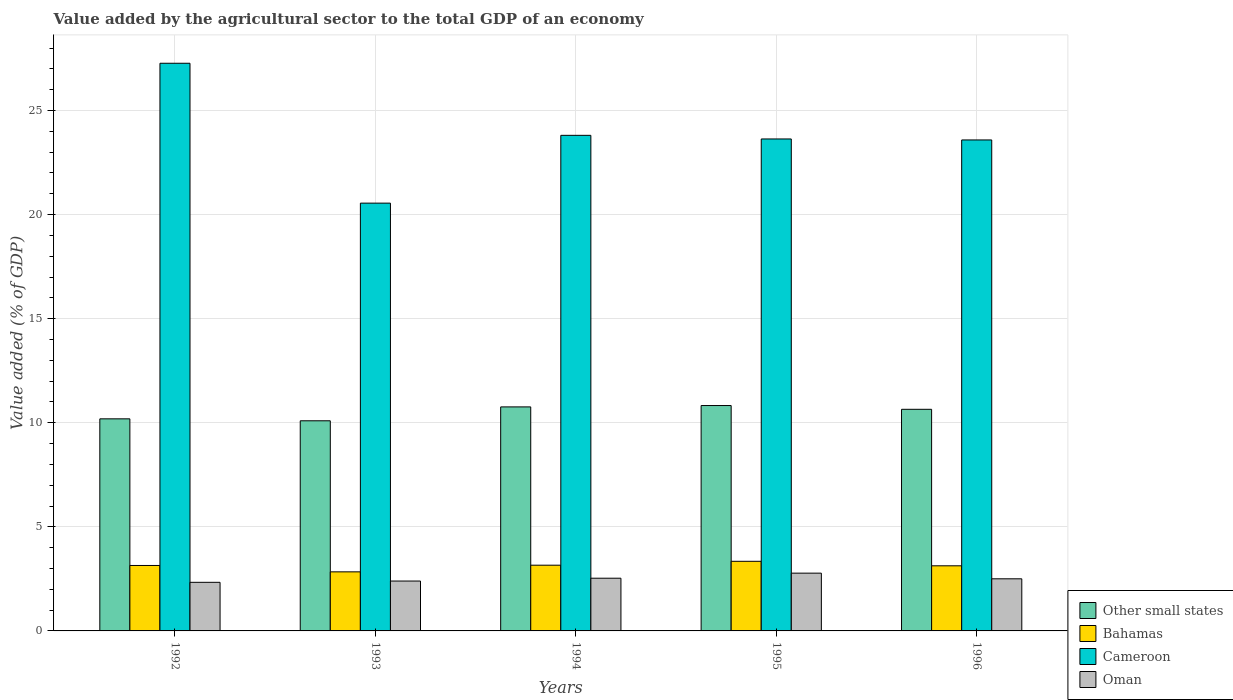Are the number of bars per tick equal to the number of legend labels?
Make the answer very short. Yes. How many bars are there on the 2nd tick from the left?
Offer a terse response. 4. How many bars are there on the 4th tick from the right?
Offer a terse response. 4. What is the label of the 2nd group of bars from the left?
Ensure brevity in your answer.  1993. What is the value added by the agricultural sector to the total GDP in Oman in 1992?
Provide a short and direct response. 2.34. Across all years, what is the maximum value added by the agricultural sector to the total GDP in Oman?
Your answer should be very brief. 2.78. Across all years, what is the minimum value added by the agricultural sector to the total GDP in Oman?
Ensure brevity in your answer.  2.34. What is the total value added by the agricultural sector to the total GDP in Other small states in the graph?
Provide a short and direct response. 52.52. What is the difference between the value added by the agricultural sector to the total GDP in Other small states in 1994 and that in 1995?
Keep it short and to the point. -0.07. What is the difference between the value added by the agricultural sector to the total GDP in Oman in 1992 and the value added by the agricultural sector to the total GDP in Other small states in 1995?
Offer a terse response. -8.49. What is the average value added by the agricultural sector to the total GDP in Oman per year?
Provide a short and direct response. 2.51. In the year 1993, what is the difference between the value added by the agricultural sector to the total GDP in Bahamas and value added by the agricultural sector to the total GDP in Oman?
Give a very brief answer. 0.44. In how many years, is the value added by the agricultural sector to the total GDP in Cameroon greater than 18 %?
Your answer should be very brief. 5. What is the ratio of the value added by the agricultural sector to the total GDP in Other small states in 1993 to that in 1994?
Make the answer very short. 0.94. Is the value added by the agricultural sector to the total GDP in Bahamas in 1993 less than that in 1996?
Make the answer very short. Yes. What is the difference between the highest and the second highest value added by the agricultural sector to the total GDP in Bahamas?
Make the answer very short. 0.19. What is the difference between the highest and the lowest value added by the agricultural sector to the total GDP in Cameroon?
Make the answer very short. 6.72. In how many years, is the value added by the agricultural sector to the total GDP in Cameroon greater than the average value added by the agricultural sector to the total GDP in Cameroon taken over all years?
Keep it short and to the point. 2. Is the sum of the value added by the agricultural sector to the total GDP in Bahamas in 1994 and 1996 greater than the maximum value added by the agricultural sector to the total GDP in Other small states across all years?
Keep it short and to the point. No. What does the 4th bar from the left in 1992 represents?
Make the answer very short. Oman. What does the 1st bar from the right in 1996 represents?
Your answer should be very brief. Oman. Is it the case that in every year, the sum of the value added by the agricultural sector to the total GDP in Cameroon and value added by the agricultural sector to the total GDP in Bahamas is greater than the value added by the agricultural sector to the total GDP in Oman?
Provide a short and direct response. Yes. How many bars are there?
Provide a succinct answer. 20. Does the graph contain any zero values?
Offer a terse response. No. Does the graph contain grids?
Your answer should be compact. Yes. How many legend labels are there?
Keep it short and to the point. 4. What is the title of the graph?
Offer a terse response. Value added by the agricultural sector to the total GDP of an economy. What is the label or title of the X-axis?
Give a very brief answer. Years. What is the label or title of the Y-axis?
Offer a terse response. Value added (% of GDP). What is the Value added (% of GDP) of Other small states in 1992?
Ensure brevity in your answer.  10.19. What is the Value added (% of GDP) of Bahamas in 1992?
Your response must be concise. 3.14. What is the Value added (% of GDP) of Cameroon in 1992?
Make the answer very short. 27.27. What is the Value added (% of GDP) of Oman in 1992?
Provide a short and direct response. 2.34. What is the Value added (% of GDP) of Other small states in 1993?
Provide a succinct answer. 10.1. What is the Value added (% of GDP) in Bahamas in 1993?
Keep it short and to the point. 2.84. What is the Value added (% of GDP) in Cameroon in 1993?
Make the answer very short. 20.55. What is the Value added (% of GDP) in Oman in 1993?
Give a very brief answer. 2.4. What is the Value added (% of GDP) of Other small states in 1994?
Your response must be concise. 10.76. What is the Value added (% of GDP) in Bahamas in 1994?
Ensure brevity in your answer.  3.16. What is the Value added (% of GDP) of Cameroon in 1994?
Provide a succinct answer. 23.81. What is the Value added (% of GDP) of Oman in 1994?
Provide a succinct answer. 2.53. What is the Value added (% of GDP) of Other small states in 1995?
Your answer should be compact. 10.83. What is the Value added (% of GDP) of Bahamas in 1995?
Offer a very short reply. 3.34. What is the Value added (% of GDP) in Cameroon in 1995?
Ensure brevity in your answer.  23.63. What is the Value added (% of GDP) in Oman in 1995?
Provide a succinct answer. 2.78. What is the Value added (% of GDP) of Other small states in 1996?
Provide a short and direct response. 10.65. What is the Value added (% of GDP) of Bahamas in 1996?
Offer a terse response. 3.13. What is the Value added (% of GDP) in Cameroon in 1996?
Provide a short and direct response. 23.59. What is the Value added (% of GDP) of Oman in 1996?
Give a very brief answer. 2.5. Across all years, what is the maximum Value added (% of GDP) of Other small states?
Offer a very short reply. 10.83. Across all years, what is the maximum Value added (% of GDP) of Bahamas?
Offer a terse response. 3.34. Across all years, what is the maximum Value added (% of GDP) of Cameroon?
Offer a very short reply. 27.27. Across all years, what is the maximum Value added (% of GDP) in Oman?
Give a very brief answer. 2.78. Across all years, what is the minimum Value added (% of GDP) in Other small states?
Your response must be concise. 10.1. Across all years, what is the minimum Value added (% of GDP) of Bahamas?
Provide a short and direct response. 2.84. Across all years, what is the minimum Value added (% of GDP) in Cameroon?
Provide a short and direct response. 20.55. Across all years, what is the minimum Value added (% of GDP) of Oman?
Provide a short and direct response. 2.34. What is the total Value added (% of GDP) of Other small states in the graph?
Your response must be concise. 52.52. What is the total Value added (% of GDP) of Bahamas in the graph?
Provide a short and direct response. 15.61. What is the total Value added (% of GDP) of Cameroon in the graph?
Provide a short and direct response. 118.85. What is the total Value added (% of GDP) in Oman in the graph?
Keep it short and to the point. 12.54. What is the difference between the Value added (% of GDP) of Other small states in 1992 and that in 1993?
Offer a terse response. 0.09. What is the difference between the Value added (% of GDP) in Bahamas in 1992 and that in 1993?
Offer a terse response. 0.31. What is the difference between the Value added (% of GDP) in Cameroon in 1992 and that in 1993?
Keep it short and to the point. 6.72. What is the difference between the Value added (% of GDP) of Oman in 1992 and that in 1993?
Provide a succinct answer. -0.06. What is the difference between the Value added (% of GDP) in Other small states in 1992 and that in 1994?
Provide a succinct answer. -0.57. What is the difference between the Value added (% of GDP) of Bahamas in 1992 and that in 1994?
Your answer should be compact. -0.01. What is the difference between the Value added (% of GDP) of Cameroon in 1992 and that in 1994?
Provide a succinct answer. 3.46. What is the difference between the Value added (% of GDP) in Oman in 1992 and that in 1994?
Offer a very short reply. -0.2. What is the difference between the Value added (% of GDP) of Other small states in 1992 and that in 1995?
Provide a short and direct response. -0.64. What is the difference between the Value added (% of GDP) in Bahamas in 1992 and that in 1995?
Ensure brevity in your answer.  -0.2. What is the difference between the Value added (% of GDP) of Cameroon in 1992 and that in 1995?
Give a very brief answer. 3.64. What is the difference between the Value added (% of GDP) of Oman in 1992 and that in 1995?
Ensure brevity in your answer.  -0.44. What is the difference between the Value added (% of GDP) of Other small states in 1992 and that in 1996?
Provide a short and direct response. -0.46. What is the difference between the Value added (% of GDP) in Bahamas in 1992 and that in 1996?
Make the answer very short. 0.02. What is the difference between the Value added (% of GDP) in Cameroon in 1992 and that in 1996?
Your response must be concise. 3.68. What is the difference between the Value added (% of GDP) in Oman in 1992 and that in 1996?
Offer a very short reply. -0.17. What is the difference between the Value added (% of GDP) in Other small states in 1993 and that in 1994?
Make the answer very short. -0.67. What is the difference between the Value added (% of GDP) of Bahamas in 1993 and that in 1994?
Keep it short and to the point. -0.32. What is the difference between the Value added (% of GDP) of Cameroon in 1993 and that in 1994?
Your response must be concise. -3.26. What is the difference between the Value added (% of GDP) in Oman in 1993 and that in 1994?
Ensure brevity in your answer.  -0.14. What is the difference between the Value added (% of GDP) of Other small states in 1993 and that in 1995?
Offer a very short reply. -0.73. What is the difference between the Value added (% of GDP) of Bahamas in 1993 and that in 1995?
Keep it short and to the point. -0.51. What is the difference between the Value added (% of GDP) of Cameroon in 1993 and that in 1995?
Keep it short and to the point. -3.08. What is the difference between the Value added (% of GDP) of Oman in 1993 and that in 1995?
Provide a succinct answer. -0.38. What is the difference between the Value added (% of GDP) in Other small states in 1993 and that in 1996?
Offer a very short reply. -0.55. What is the difference between the Value added (% of GDP) of Bahamas in 1993 and that in 1996?
Offer a terse response. -0.29. What is the difference between the Value added (% of GDP) of Cameroon in 1993 and that in 1996?
Your response must be concise. -3.04. What is the difference between the Value added (% of GDP) of Oman in 1993 and that in 1996?
Your answer should be compact. -0.11. What is the difference between the Value added (% of GDP) of Other small states in 1994 and that in 1995?
Your response must be concise. -0.07. What is the difference between the Value added (% of GDP) in Bahamas in 1994 and that in 1995?
Give a very brief answer. -0.19. What is the difference between the Value added (% of GDP) of Cameroon in 1994 and that in 1995?
Your answer should be compact. 0.17. What is the difference between the Value added (% of GDP) in Oman in 1994 and that in 1995?
Give a very brief answer. -0.24. What is the difference between the Value added (% of GDP) in Other small states in 1994 and that in 1996?
Offer a terse response. 0.12. What is the difference between the Value added (% of GDP) in Bahamas in 1994 and that in 1996?
Your answer should be compact. 0.03. What is the difference between the Value added (% of GDP) of Cameroon in 1994 and that in 1996?
Offer a very short reply. 0.22. What is the difference between the Value added (% of GDP) in Oman in 1994 and that in 1996?
Your answer should be compact. 0.03. What is the difference between the Value added (% of GDP) of Other small states in 1995 and that in 1996?
Make the answer very short. 0.18. What is the difference between the Value added (% of GDP) in Bahamas in 1995 and that in 1996?
Ensure brevity in your answer.  0.22. What is the difference between the Value added (% of GDP) in Cameroon in 1995 and that in 1996?
Offer a very short reply. 0.05. What is the difference between the Value added (% of GDP) of Oman in 1995 and that in 1996?
Give a very brief answer. 0.27. What is the difference between the Value added (% of GDP) of Other small states in 1992 and the Value added (% of GDP) of Bahamas in 1993?
Provide a succinct answer. 7.35. What is the difference between the Value added (% of GDP) of Other small states in 1992 and the Value added (% of GDP) of Cameroon in 1993?
Make the answer very short. -10.36. What is the difference between the Value added (% of GDP) in Other small states in 1992 and the Value added (% of GDP) in Oman in 1993?
Your answer should be very brief. 7.79. What is the difference between the Value added (% of GDP) of Bahamas in 1992 and the Value added (% of GDP) of Cameroon in 1993?
Give a very brief answer. -17.41. What is the difference between the Value added (% of GDP) of Bahamas in 1992 and the Value added (% of GDP) of Oman in 1993?
Keep it short and to the point. 0.75. What is the difference between the Value added (% of GDP) of Cameroon in 1992 and the Value added (% of GDP) of Oman in 1993?
Your answer should be compact. 24.88. What is the difference between the Value added (% of GDP) in Other small states in 1992 and the Value added (% of GDP) in Bahamas in 1994?
Offer a very short reply. 7.03. What is the difference between the Value added (% of GDP) of Other small states in 1992 and the Value added (% of GDP) of Cameroon in 1994?
Provide a short and direct response. -13.62. What is the difference between the Value added (% of GDP) in Other small states in 1992 and the Value added (% of GDP) in Oman in 1994?
Keep it short and to the point. 7.66. What is the difference between the Value added (% of GDP) in Bahamas in 1992 and the Value added (% of GDP) in Cameroon in 1994?
Offer a terse response. -20.66. What is the difference between the Value added (% of GDP) of Bahamas in 1992 and the Value added (% of GDP) of Oman in 1994?
Keep it short and to the point. 0.61. What is the difference between the Value added (% of GDP) of Cameroon in 1992 and the Value added (% of GDP) of Oman in 1994?
Your answer should be very brief. 24.74. What is the difference between the Value added (% of GDP) of Other small states in 1992 and the Value added (% of GDP) of Bahamas in 1995?
Offer a terse response. 6.84. What is the difference between the Value added (% of GDP) in Other small states in 1992 and the Value added (% of GDP) in Cameroon in 1995?
Your answer should be compact. -13.45. What is the difference between the Value added (% of GDP) in Other small states in 1992 and the Value added (% of GDP) in Oman in 1995?
Give a very brief answer. 7.41. What is the difference between the Value added (% of GDP) of Bahamas in 1992 and the Value added (% of GDP) of Cameroon in 1995?
Make the answer very short. -20.49. What is the difference between the Value added (% of GDP) in Bahamas in 1992 and the Value added (% of GDP) in Oman in 1995?
Your answer should be compact. 0.37. What is the difference between the Value added (% of GDP) in Cameroon in 1992 and the Value added (% of GDP) in Oman in 1995?
Your answer should be very brief. 24.5. What is the difference between the Value added (% of GDP) in Other small states in 1992 and the Value added (% of GDP) in Bahamas in 1996?
Provide a succinct answer. 7.06. What is the difference between the Value added (% of GDP) in Other small states in 1992 and the Value added (% of GDP) in Cameroon in 1996?
Provide a short and direct response. -13.4. What is the difference between the Value added (% of GDP) of Other small states in 1992 and the Value added (% of GDP) of Oman in 1996?
Make the answer very short. 7.68. What is the difference between the Value added (% of GDP) of Bahamas in 1992 and the Value added (% of GDP) of Cameroon in 1996?
Make the answer very short. -20.44. What is the difference between the Value added (% of GDP) in Bahamas in 1992 and the Value added (% of GDP) in Oman in 1996?
Your answer should be very brief. 0.64. What is the difference between the Value added (% of GDP) of Cameroon in 1992 and the Value added (% of GDP) of Oman in 1996?
Make the answer very short. 24.77. What is the difference between the Value added (% of GDP) of Other small states in 1993 and the Value added (% of GDP) of Bahamas in 1994?
Give a very brief answer. 6.94. What is the difference between the Value added (% of GDP) in Other small states in 1993 and the Value added (% of GDP) in Cameroon in 1994?
Provide a succinct answer. -13.71. What is the difference between the Value added (% of GDP) in Other small states in 1993 and the Value added (% of GDP) in Oman in 1994?
Make the answer very short. 7.56. What is the difference between the Value added (% of GDP) in Bahamas in 1993 and the Value added (% of GDP) in Cameroon in 1994?
Your response must be concise. -20.97. What is the difference between the Value added (% of GDP) of Bahamas in 1993 and the Value added (% of GDP) of Oman in 1994?
Provide a short and direct response. 0.31. What is the difference between the Value added (% of GDP) of Cameroon in 1993 and the Value added (% of GDP) of Oman in 1994?
Offer a terse response. 18.02. What is the difference between the Value added (% of GDP) in Other small states in 1993 and the Value added (% of GDP) in Bahamas in 1995?
Ensure brevity in your answer.  6.75. What is the difference between the Value added (% of GDP) in Other small states in 1993 and the Value added (% of GDP) in Cameroon in 1995?
Provide a short and direct response. -13.54. What is the difference between the Value added (% of GDP) of Other small states in 1993 and the Value added (% of GDP) of Oman in 1995?
Your response must be concise. 7.32. What is the difference between the Value added (% of GDP) in Bahamas in 1993 and the Value added (% of GDP) in Cameroon in 1995?
Make the answer very short. -20.8. What is the difference between the Value added (% of GDP) in Bahamas in 1993 and the Value added (% of GDP) in Oman in 1995?
Your answer should be compact. 0.06. What is the difference between the Value added (% of GDP) of Cameroon in 1993 and the Value added (% of GDP) of Oman in 1995?
Your answer should be very brief. 17.78. What is the difference between the Value added (% of GDP) of Other small states in 1993 and the Value added (% of GDP) of Bahamas in 1996?
Your response must be concise. 6.97. What is the difference between the Value added (% of GDP) of Other small states in 1993 and the Value added (% of GDP) of Cameroon in 1996?
Offer a very short reply. -13.49. What is the difference between the Value added (% of GDP) of Other small states in 1993 and the Value added (% of GDP) of Oman in 1996?
Your answer should be compact. 7.59. What is the difference between the Value added (% of GDP) of Bahamas in 1993 and the Value added (% of GDP) of Cameroon in 1996?
Offer a very short reply. -20.75. What is the difference between the Value added (% of GDP) of Bahamas in 1993 and the Value added (% of GDP) of Oman in 1996?
Your answer should be very brief. 0.33. What is the difference between the Value added (% of GDP) in Cameroon in 1993 and the Value added (% of GDP) in Oman in 1996?
Your answer should be compact. 18.05. What is the difference between the Value added (% of GDP) of Other small states in 1994 and the Value added (% of GDP) of Bahamas in 1995?
Offer a terse response. 7.42. What is the difference between the Value added (% of GDP) in Other small states in 1994 and the Value added (% of GDP) in Cameroon in 1995?
Offer a very short reply. -12.87. What is the difference between the Value added (% of GDP) of Other small states in 1994 and the Value added (% of GDP) of Oman in 1995?
Make the answer very short. 7.99. What is the difference between the Value added (% of GDP) of Bahamas in 1994 and the Value added (% of GDP) of Cameroon in 1995?
Give a very brief answer. -20.48. What is the difference between the Value added (% of GDP) in Bahamas in 1994 and the Value added (% of GDP) in Oman in 1995?
Make the answer very short. 0.38. What is the difference between the Value added (% of GDP) of Cameroon in 1994 and the Value added (% of GDP) of Oman in 1995?
Keep it short and to the point. 21.03. What is the difference between the Value added (% of GDP) of Other small states in 1994 and the Value added (% of GDP) of Bahamas in 1996?
Provide a succinct answer. 7.63. What is the difference between the Value added (% of GDP) in Other small states in 1994 and the Value added (% of GDP) in Cameroon in 1996?
Offer a very short reply. -12.82. What is the difference between the Value added (% of GDP) in Other small states in 1994 and the Value added (% of GDP) in Oman in 1996?
Ensure brevity in your answer.  8.26. What is the difference between the Value added (% of GDP) in Bahamas in 1994 and the Value added (% of GDP) in Cameroon in 1996?
Make the answer very short. -20.43. What is the difference between the Value added (% of GDP) in Bahamas in 1994 and the Value added (% of GDP) in Oman in 1996?
Offer a very short reply. 0.65. What is the difference between the Value added (% of GDP) of Cameroon in 1994 and the Value added (% of GDP) of Oman in 1996?
Give a very brief answer. 21.3. What is the difference between the Value added (% of GDP) of Other small states in 1995 and the Value added (% of GDP) of Bahamas in 1996?
Your answer should be compact. 7.7. What is the difference between the Value added (% of GDP) of Other small states in 1995 and the Value added (% of GDP) of Cameroon in 1996?
Provide a short and direct response. -12.76. What is the difference between the Value added (% of GDP) of Other small states in 1995 and the Value added (% of GDP) of Oman in 1996?
Give a very brief answer. 8.32. What is the difference between the Value added (% of GDP) of Bahamas in 1995 and the Value added (% of GDP) of Cameroon in 1996?
Provide a short and direct response. -20.24. What is the difference between the Value added (% of GDP) in Bahamas in 1995 and the Value added (% of GDP) in Oman in 1996?
Make the answer very short. 0.84. What is the difference between the Value added (% of GDP) in Cameroon in 1995 and the Value added (% of GDP) in Oman in 1996?
Keep it short and to the point. 21.13. What is the average Value added (% of GDP) in Other small states per year?
Provide a short and direct response. 10.5. What is the average Value added (% of GDP) of Bahamas per year?
Give a very brief answer. 3.12. What is the average Value added (% of GDP) in Cameroon per year?
Provide a succinct answer. 23.77. What is the average Value added (% of GDP) in Oman per year?
Ensure brevity in your answer.  2.51. In the year 1992, what is the difference between the Value added (% of GDP) in Other small states and Value added (% of GDP) in Bahamas?
Offer a terse response. 7.04. In the year 1992, what is the difference between the Value added (% of GDP) of Other small states and Value added (% of GDP) of Cameroon?
Provide a succinct answer. -17.08. In the year 1992, what is the difference between the Value added (% of GDP) in Other small states and Value added (% of GDP) in Oman?
Keep it short and to the point. 7.85. In the year 1992, what is the difference between the Value added (% of GDP) in Bahamas and Value added (% of GDP) in Cameroon?
Your response must be concise. -24.13. In the year 1992, what is the difference between the Value added (% of GDP) in Bahamas and Value added (% of GDP) in Oman?
Provide a succinct answer. 0.81. In the year 1992, what is the difference between the Value added (% of GDP) of Cameroon and Value added (% of GDP) of Oman?
Provide a succinct answer. 24.94. In the year 1993, what is the difference between the Value added (% of GDP) in Other small states and Value added (% of GDP) in Bahamas?
Offer a very short reply. 7.26. In the year 1993, what is the difference between the Value added (% of GDP) in Other small states and Value added (% of GDP) in Cameroon?
Provide a succinct answer. -10.46. In the year 1993, what is the difference between the Value added (% of GDP) of Other small states and Value added (% of GDP) of Oman?
Offer a very short reply. 7.7. In the year 1993, what is the difference between the Value added (% of GDP) of Bahamas and Value added (% of GDP) of Cameroon?
Your answer should be very brief. -17.71. In the year 1993, what is the difference between the Value added (% of GDP) of Bahamas and Value added (% of GDP) of Oman?
Give a very brief answer. 0.44. In the year 1993, what is the difference between the Value added (% of GDP) in Cameroon and Value added (% of GDP) in Oman?
Ensure brevity in your answer.  18.16. In the year 1994, what is the difference between the Value added (% of GDP) in Other small states and Value added (% of GDP) in Bahamas?
Your response must be concise. 7.61. In the year 1994, what is the difference between the Value added (% of GDP) in Other small states and Value added (% of GDP) in Cameroon?
Your response must be concise. -13.05. In the year 1994, what is the difference between the Value added (% of GDP) in Other small states and Value added (% of GDP) in Oman?
Offer a terse response. 8.23. In the year 1994, what is the difference between the Value added (% of GDP) of Bahamas and Value added (% of GDP) of Cameroon?
Ensure brevity in your answer.  -20.65. In the year 1994, what is the difference between the Value added (% of GDP) in Bahamas and Value added (% of GDP) in Oman?
Your answer should be compact. 0.62. In the year 1994, what is the difference between the Value added (% of GDP) of Cameroon and Value added (% of GDP) of Oman?
Your answer should be compact. 21.28. In the year 1995, what is the difference between the Value added (% of GDP) in Other small states and Value added (% of GDP) in Bahamas?
Your response must be concise. 7.48. In the year 1995, what is the difference between the Value added (% of GDP) of Other small states and Value added (% of GDP) of Cameroon?
Your answer should be compact. -12.81. In the year 1995, what is the difference between the Value added (% of GDP) of Other small states and Value added (% of GDP) of Oman?
Give a very brief answer. 8.05. In the year 1995, what is the difference between the Value added (% of GDP) in Bahamas and Value added (% of GDP) in Cameroon?
Give a very brief answer. -20.29. In the year 1995, what is the difference between the Value added (% of GDP) of Bahamas and Value added (% of GDP) of Oman?
Give a very brief answer. 0.57. In the year 1995, what is the difference between the Value added (% of GDP) of Cameroon and Value added (% of GDP) of Oman?
Offer a very short reply. 20.86. In the year 1996, what is the difference between the Value added (% of GDP) of Other small states and Value added (% of GDP) of Bahamas?
Make the answer very short. 7.52. In the year 1996, what is the difference between the Value added (% of GDP) in Other small states and Value added (% of GDP) in Cameroon?
Provide a short and direct response. -12.94. In the year 1996, what is the difference between the Value added (% of GDP) of Other small states and Value added (% of GDP) of Oman?
Your response must be concise. 8.14. In the year 1996, what is the difference between the Value added (% of GDP) of Bahamas and Value added (% of GDP) of Cameroon?
Your response must be concise. -20.46. In the year 1996, what is the difference between the Value added (% of GDP) in Bahamas and Value added (% of GDP) in Oman?
Offer a terse response. 0.62. In the year 1996, what is the difference between the Value added (% of GDP) in Cameroon and Value added (% of GDP) in Oman?
Offer a terse response. 21.08. What is the ratio of the Value added (% of GDP) of Other small states in 1992 to that in 1993?
Ensure brevity in your answer.  1.01. What is the ratio of the Value added (% of GDP) in Bahamas in 1992 to that in 1993?
Give a very brief answer. 1.11. What is the ratio of the Value added (% of GDP) in Cameroon in 1992 to that in 1993?
Provide a succinct answer. 1.33. What is the ratio of the Value added (% of GDP) of Oman in 1992 to that in 1993?
Ensure brevity in your answer.  0.97. What is the ratio of the Value added (% of GDP) of Other small states in 1992 to that in 1994?
Offer a very short reply. 0.95. What is the ratio of the Value added (% of GDP) in Cameroon in 1992 to that in 1994?
Your response must be concise. 1.15. What is the ratio of the Value added (% of GDP) of Oman in 1992 to that in 1994?
Provide a short and direct response. 0.92. What is the ratio of the Value added (% of GDP) of Other small states in 1992 to that in 1995?
Your answer should be compact. 0.94. What is the ratio of the Value added (% of GDP) in Bahamas in 1992 to that in 1995?
Keep it short and to the point. 0.94. What is the ratio of the Value added (% of GDP) of Cameroon in 1992 to that in 1995?
Ensure brevity in your answer.  1.15. What is the ratio of the Value added (% of GDP) in Oman in 1992 to that in 1995?
Provide a short and direct response. 0.84. What is the ratio of the Value added (% of GDP) in Cameroon in 1992 to that in 1996?
Offer a very short reply. 1.16. What is the ratio of the Value added (% of GDP) in Oman in 1992 to that in 1996?
Your response must be concise. 0.93. What is the ratio of the Value added (% of GDP) in Other small states in 1993 to that in 1994?
Your answer should be compact. 0.94. What is the ratio of the Value added (% of GDP) in Bahamas in 1993 to that in 1994?
Provide a short and direct response. 0.9. What is the ratio of the Value added (% of GDP) in Cameroon in 1993 to that in 1994?
Make the answer very short. 0.86. What is the ratio of the Value added (% of GDP) of Oman in 1993 to that in 1994?
Your answer should be compact. 0.95. What is the ratio of the Value added (% of GDP) in Other small states in 1993 to that in 1995?
Provide a succinct answer. 0.93. What is the ratio of the Value added (% of GDP) of Bahamas in 1993 to that in 1995?
Provide a short and direct response. 0.85. What is the ratio of the Value added (% of GDP) of Cameroon in 1993 to that in 1995?
Offer a very short reply. 0.87. What is the ratio of the Value added (% of GDP) in Oman in 1993 to that in 1995?
Keep it short and to the point. 0.86. What is the ratio of the Value added (% of GDP) of Other small states in 1993 to that in 1996?
Your answer should be very brief. 0.95. What is the ratio of the Value added (% of GDP) of Bahamas in 1993 to that in 1996?
Your response must be concise. 0.91. What is the ratio of the Value added (% of GDP) of Cameroon in 1993 to that in 1996?
Ensure brevity in your answer.  0.87. What is the ratio of the Value added (% of GDP) of Oman in 1993 to that in 1996?
Provide a short and direct response. 0.96. What is the ratio of the Value added (% of GDP) in Bahamas in 1994 to that in 1995?
Make the answer very short. 0.94. What is the ratio of the Value added (% of GDP) in Cameroon in 1994 to that in 1995?
Provide a succinct answer. 1.01. What is the ratio of the Value added (% of GDP) in Oman in 1994 to that in 1995?
Provide a succinct answer. 0.91. What is the ratio of the Value added (% of GDP) in Other small states in 1994 to that in 1996?
Ensure brevity in your answer.  1.01. What is the ratio of the Value added (% of GDP) in Bahamas in 1994 to that in 1996?
Give a very brief answer. 1.01. What is the ratio of the Value added (% of GDP) of Cameroon in 1994 to that in 1996?
Provide a succinct answer. 1.01. What is the ratio of the Value added (% of GDP) in Oman in 1994 to that in 1996?
Keep it short and to the point. 1.01. What is the ratio of the Value added (% of GDP) of Bahamas in 1995 to that in 1996?
Your answer should be very brief. 1.07. What is the ratio of the Value added (% of GDP) in Cameroon in 1995 to that in 1996?
Give a very brief answer. 1. What is the ratio of the Value added (% of GDP) of Oman in 1995 to that in 1996?
Ensure brevity in your answer.  1.11. What is the difference between the highest and the second highest Value added (% of GDP) in Other small states?
Keep it short and to the point. 0.07. What is the difference between the highest and the second highest Value added (% of GDP) in Bahamas?
Make the answer very short. 0.19. What is the difference between the highest and the second highest Value added (% of GDP) of Cameroon?
Provide a succinct answer. 3.46. What is the difference between the highest and the second highest Value added (% of GDP) of Oman?
Provide a short and direct response. 0.24. What is the difference between the highest and the lowest Value added (% of GDP) of Other small states?
Your answer should be compact. 0.73. What is the difference between the highest and the lowest Value added (% of GDP) in Bahamas?
Your response must be concise. 0.51. What is the difference between the highest and the lowest Value added (% of GDP) in Cameroon?
Keep it short and to the point. 6.72. What is the difference between the highest and the lowest Value added (% of GDP) of Oman?
Keep it short and to the point. 0.44. 